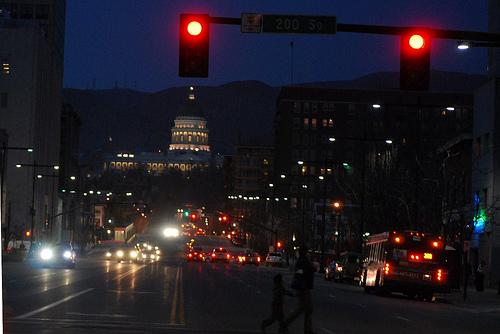Give a detailed description of the main elements of the image in one sentence. The image captures a lively nighttime street scene with cars, buses, people, red traffic lights, road markings, and illuminated buildings in the background. Highlight the key elements observed in the background of the image. The background features the lit US Capitol building at night, a large building, a tall building on the left, and many street lights along the sidewalk. Describe the overall atmosphere portrayed by the image. The image conveys a bustling urban night scene with traffic and people moving about, while the Capitol building stands majestically lit in the background. Mention the markings visible on the road. There are two yellow lines, two white arrows, and one white line on the road. Enumerate the types of transportation depicted in the image. Cars and buses are the modes of transportation visible in the image. Describe the condition of the sky and any related features. The sky is dark, suggesting it's nighttime. Mention the state of the traffic lights and any related elements in the image. There are two red traffic lights in the image, with one being closer and another in the distance, both indicating stopped traffic. Describe the vehicles visible in the image including their position and direction. Several cars are driving on the street, a bus is parked on the curb, another bus is traveling in the opposite direction, and many headlights and taillights are visible from other vehicles. List the actions taken by the people in the image. Two people are walking on the sidewalk and a group is crossing the street. Provide a brief summary of the scene depicted in the image. The image shows a busy street at night with cars, red traffic lights, people crossing the street, and a lit Capitol building in the background. 